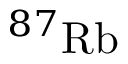Convert formula to latex. <formula><loc_0><loc_0><loc_500><loc_500>^ { 8 7 } R b</formula> 